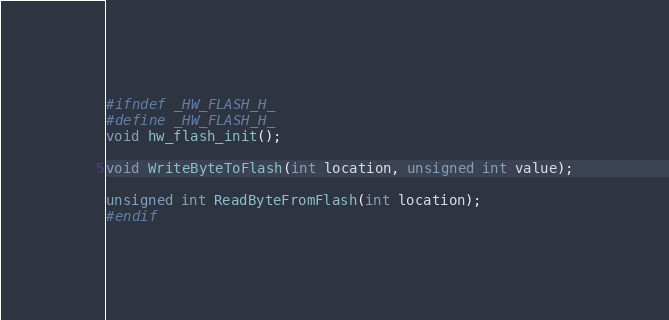Convert code to text. <code><loc_0><loc_0><loc_500><loc_500><_C_>#ifndef _HW_FLASH_H_
#define _HW_FLASH_H_
void hw_flash_init();

void WriteByteToFlash(int location, unsigned int value);

unsigned int ReadByteFromFlash(int location);
#endif</code> 